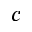<formula> <loc_0><loc_0><loc_500><loc_500>c</formula> 